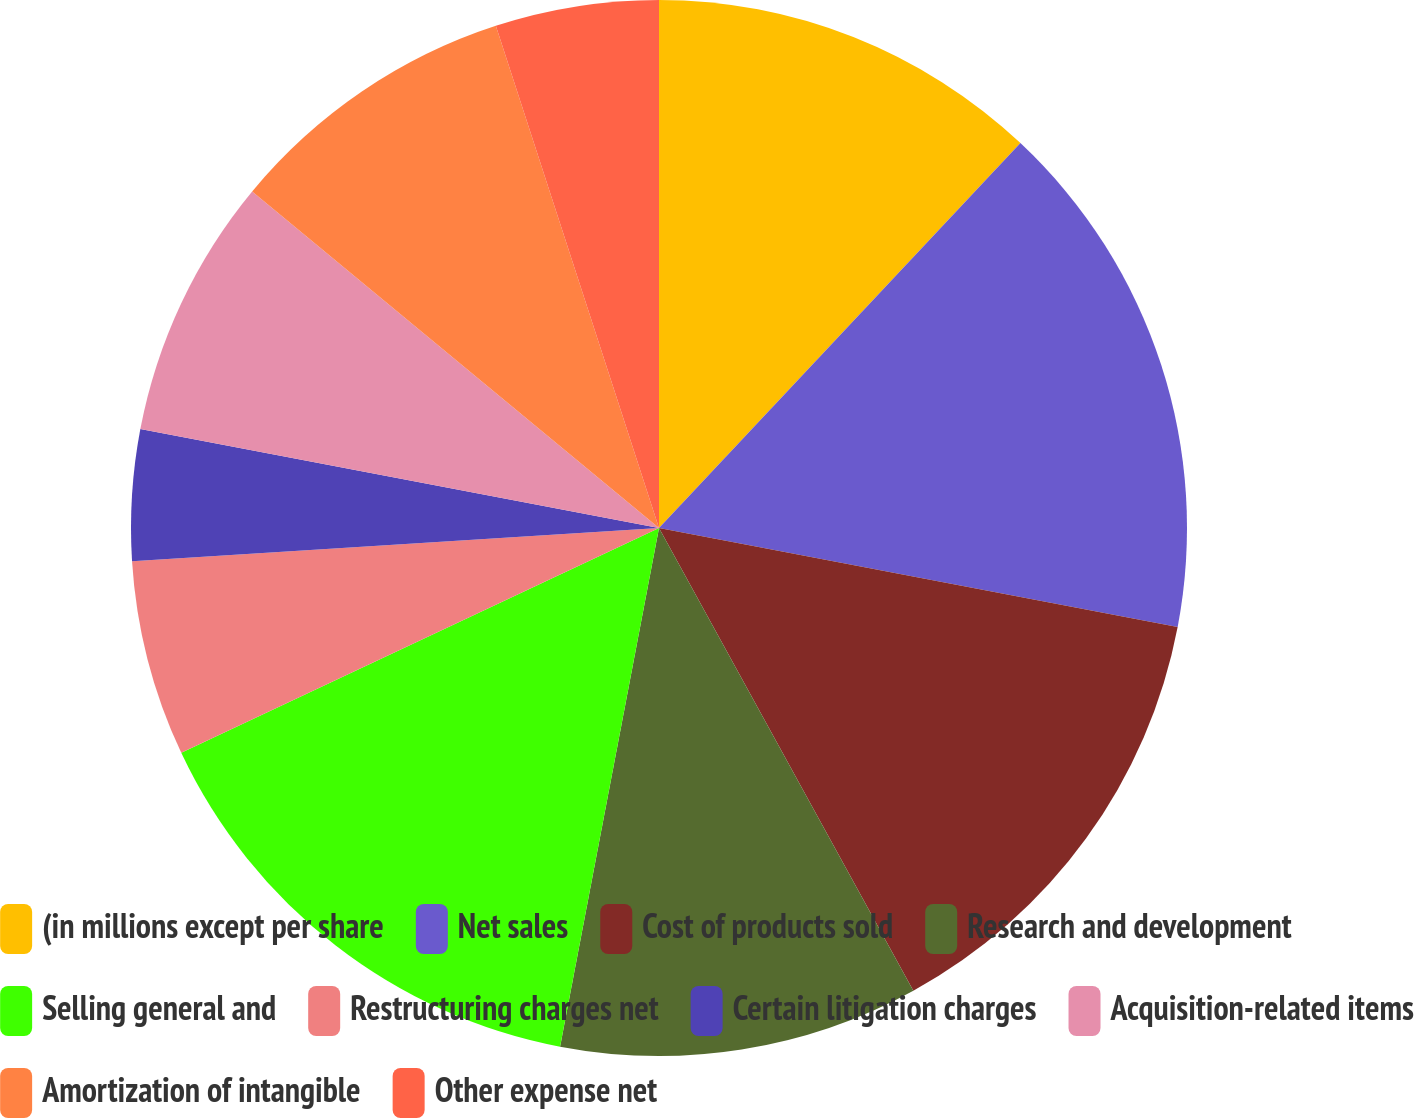<chart> <loc_0><loc_0><loc_500><loc_500><pie_chart><fcel>(in millions except per share<fcel>Net sales<fcel>Cost of products sold<fcel>Research and development<fcel>Selling general and<fcel>Restructuring charges net<fcel>Certain litigation charges<fcel>Acquisition-related items<fcel>Amortization of intangible<fcel>Other expense net<nl><fcel>12.0%<fcel>16.0%<fcel>14.0%<fcel>11.0%<fcel>15.0%<fcel>6.0%<fcel>4.0%<fcel>8.0%<fcel>9.0%<fcel>5.0%<nl></chart> 